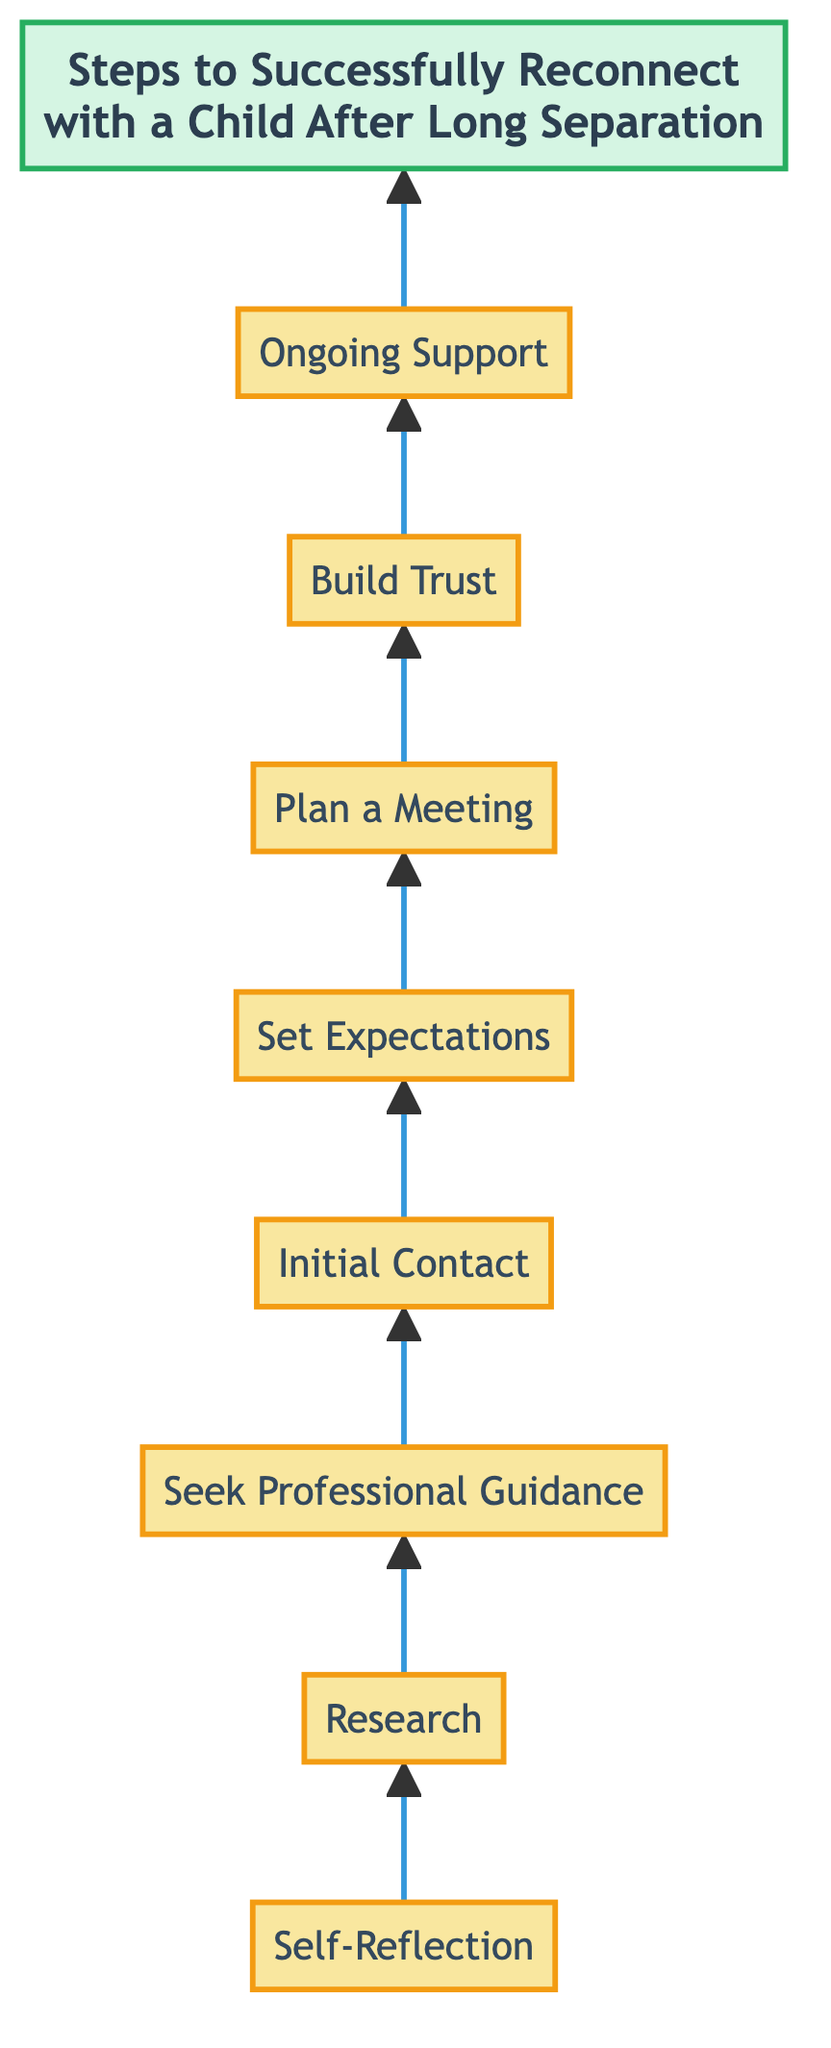What is the first step in reconnecting with a child? The diagram indicates that the first step is "Self-Reflection." It is the starting point and is directly listed at the bottom of the flowchart.
Answer: Self-Reflection How many total steps are involved in the process? By counting each step represented in the diagram from "Self-Reflection" to "Ongoing Support," there are a total of eight distinct steps shown.
Answer: 8 What is the last step in the reconnecting process? The final step, located at the top of the flowchart, is "Ongoing Support." It signifies the continuous effort required in building a healthy relationship.
Answer: Ongoing Support Which steps require professional guidance? Based on the flow of the diagram, "Seek Professional Guidance" and "Ongoing Support" both directly suggest involvement of professional help in the reconnection process.
Answer: Seek Professional Guidance, Ongoing Support What step comes after "Initial Contact"? According to the diagram, "Initial Contact" is followed by the step "Set Expectations." This indicates the next action to be taken following the initial outreach.
Answer: Set Expectations What are two steps that emphasize communication? The steps "Set Expectations" and "Build Trust" both highlight the importance of communication. They involve expressing intentions and maintaining trustworthy dialogue.
Answer: Set Expectations, Build Trust Which step focuses on gathering information? The step titled "Research" specifically emphasizes the need for gathering information about the child's current life situation to prepare for reconnection.
Answer: Research What does the title of the diagram summarize? The title "Steps to Successfully Reconnect with a Child After Long Separation" succinctly summarizes the overall intent of the flowchart, which is to outline the process of reconnecting.
Answer: Steps to Successfully Reconnect with a Child After Long Separation What relationship exists between "Plan a Meeting" and "Set Expectations"? In the flowchart, "Plan a Meeting" comes after "Set Expectations." This indicates that having clear expectations is important before arranging a meeting for reconnection.
Answer: Sequential relationship 